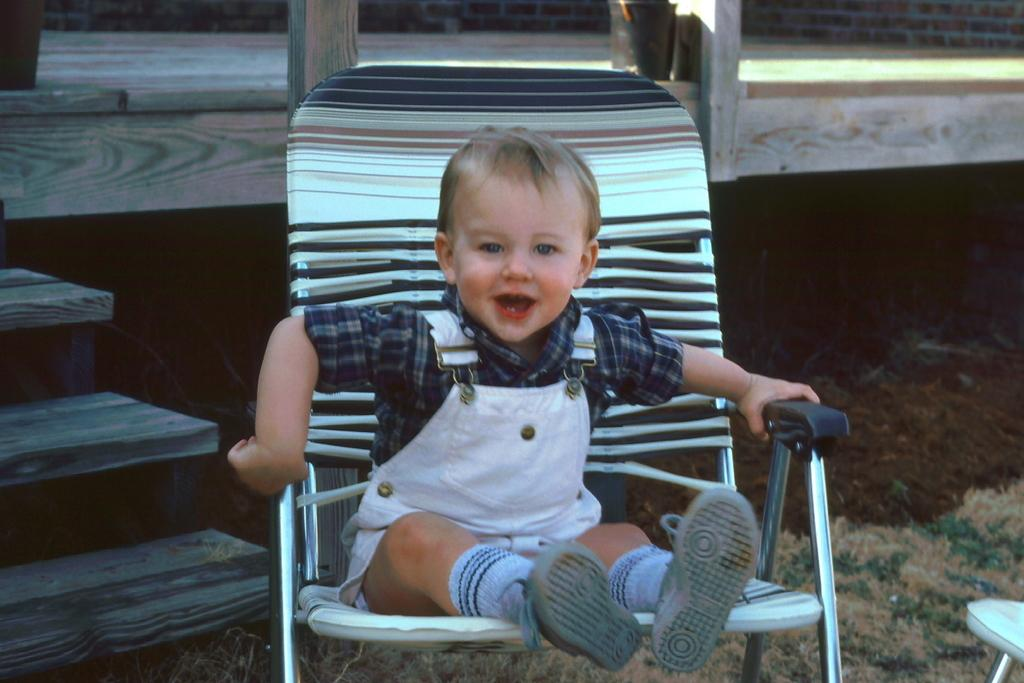What is the main subject of the image? There is a baby in the image. What is the baby wearing? The baby is wearing a white and black dress. Where is the baby sitting? The baby is sitting on a chair. What can be seen in the background of the image? There is a wooden wall and steps in the background of the image. What type of steel structure can be seen in the image? There is no steel structure present in the image. Can you hear the sound of thunder in the image? There is no sound or indication of thunder in the image. 